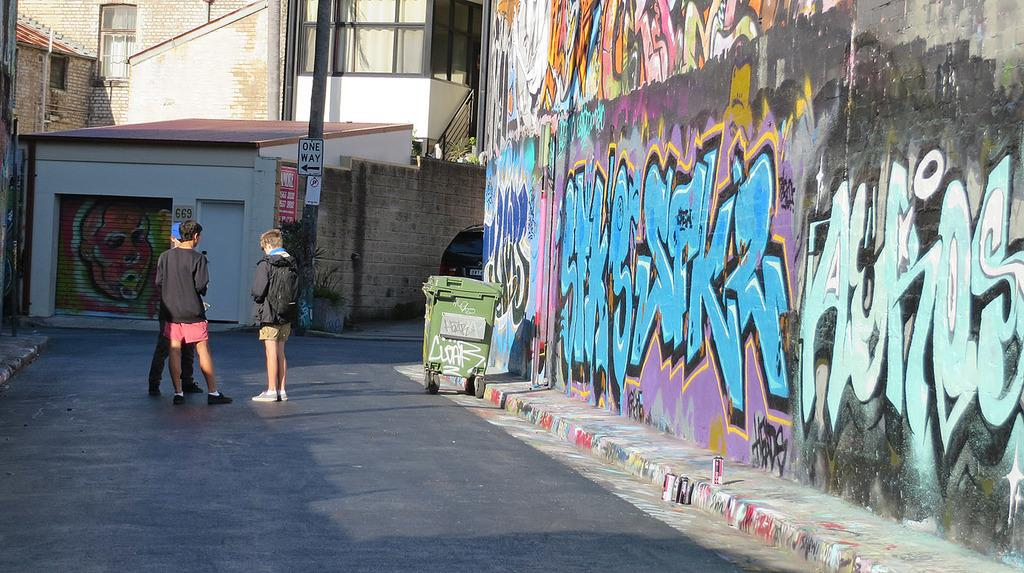What can be seen on the road in the image? There are people on the road and a container in the image. What type of structures are visible in the image? There are buildings, a house, and a wall with art in the image. What additional items can be seen in the image? There are posters, boards, and poles in the image. What type of silk is being used to create the stream in the image? There is no silk or stream present in the image. What organization is responsible for the art on the wall in the image? The image does not provide information about the organization responsible for the art on the wall. 